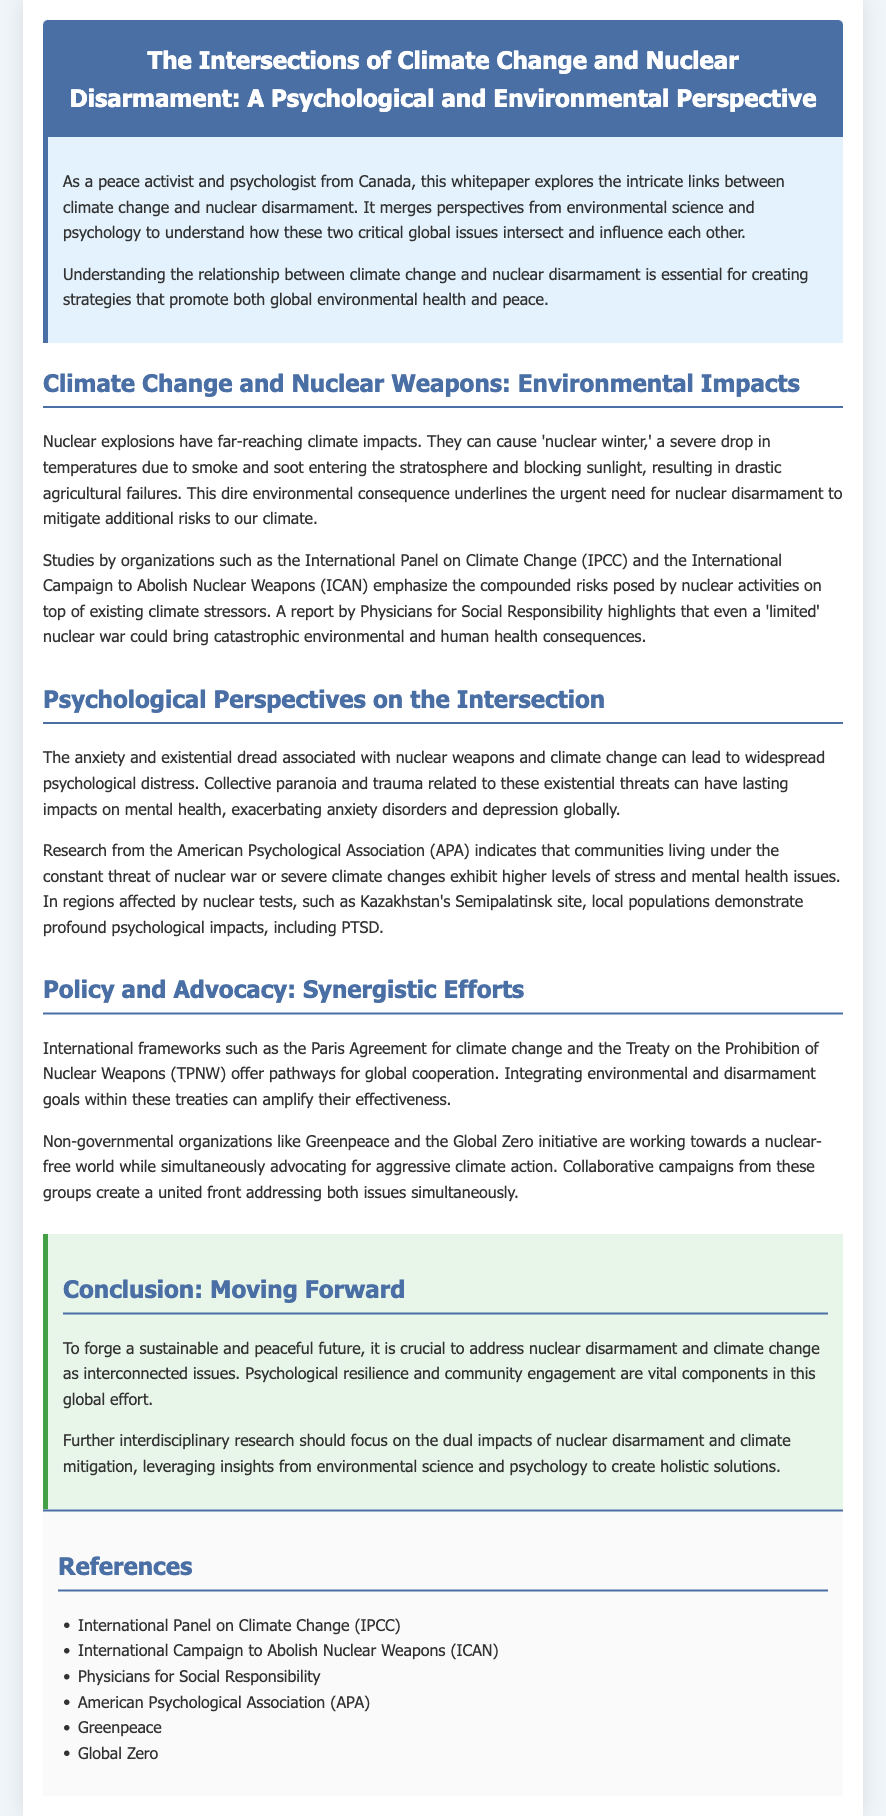What is the title of the whitepaper? The title of the whitepaper is prominently displayed at the beginning of the document.
Answer: The Intersections of Climate Change and Nuclear Disarmament: A Psychological and Environmental Perspective What is one consequence of nuclear explosions mentioned in the document? The document lists several environmental impacts of nuclear explosions, specifically mentioning one critical consequence.
Answer: Nuclear winter Which organization emphasizes the compounded risks posed by nuclear activities? The document mentions a specific organization that highlights the compounded risks associated with nuclear activities alongside climate stressors.
Answer: International Panel on Climate Change (IPCC) What psychological condition is noted as being exacerbated by the threat of nuclear war? The document discusses the mental health impacts related to nuclear threats, highlighting a particular psychological issue that is affected.
Answer: PTSD Which treaty aims to prohibit nuclear weapons? The whitepaper references a specific treaty that is focused on nuclear disarmament in its policy section.
Answer: Treaty on the Prohibition of Nuclear Weapons (TPNW) What are two organizations mentioned that advocate for a nuclear-free world? The whitepaper lists several NGOs working towards disarmament and environmental action, specifically highlighting two of them.
Answer: Greenpeace and Global Zero What is a vital component for addressing global issues mentioned in the conclusion? The conclusion emphasizes an essential aspect in progressing towards peace and sustainability that involves community involvement.
Answer: Psychological resilience How does the whitepaper suggest advancing the effectiveness of international agreements? The document provides insights on how to strengthen global cooperation in relation to climate and disarmament initiatives.
Answer: Integrating environmental and disarmament goals What is identified as a key component in global efforts for peace and sustainability? The whitepaper concludes by underscoring an important element necessary for moving forward in achieving sustainable and peaceful outcomes.
Answer: Community engagement 